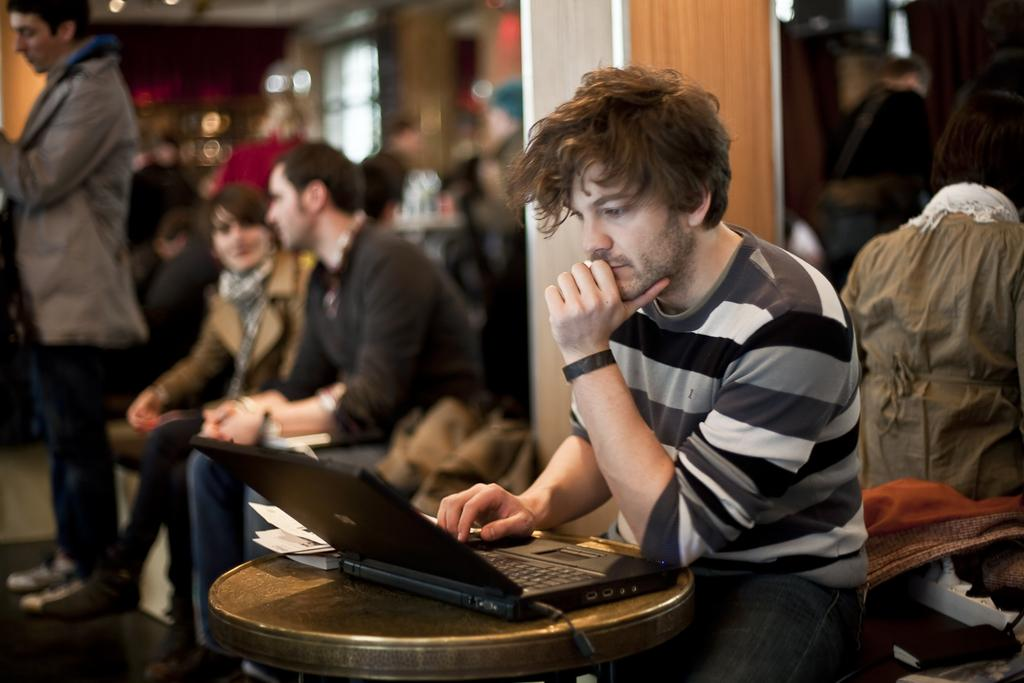What is the person in the image doing? There is a person sitting in the image. What object is on the table in front of the person? There is a laptop on the table in front of the person. What else is on the table in front of the person? There are papers and a book on the table in front of the person. Can you describe the people sitting at the back side of the image? The people sitting at the back side of the image are blurred. How many kittens are playing with the laptop in the image? There are no kittens present in the image. What type of party is happening in the image? There is no party happening in the image. 